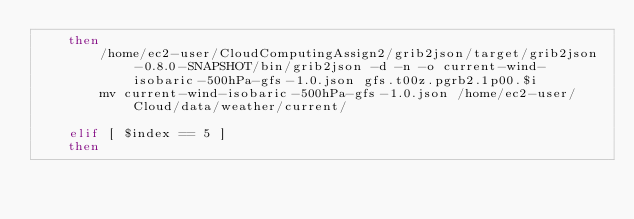Convert code to text. <code><loc_0><loc_0><loc_500><loc_500><_Bash_>	then
		/home/ec2-user/CloudComputingAssign2/grib2json/target/grib2json-0.8.0-SNAPSHOT/bin/grib2json -d -n -o current-wind-isobaric-500hPa-gfs-1.0.json gfs.t00z.pgrb2.1p00.$i
		mv current-wind-isobaric-500hPa-gfs-1.0.json /home/ec2-user/Cloud/data/weather/current/
		
	elif [ $index == 5 ]
	then</code> 